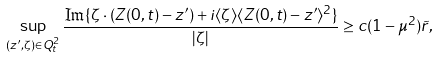<formula> <loc_0><loc_0><loc_500><loc_500>\sup _ { ( z ^ { \prime } , \zeta ) \in Q _ { t } ^ { 2 } } \frac { \Im \{ \zeta \cdot ( Z ( 0 , t ) - z ^ { \prime } ) + i \langle \zeta \rangle \langle Z ( 0 , t ) - z ^ { \prime } \rangle ^ { 2 } \} } { | \zeta | } \geq c ( 1 - \mu ^ { 2 } ) \tilde { r } ,</formula> 